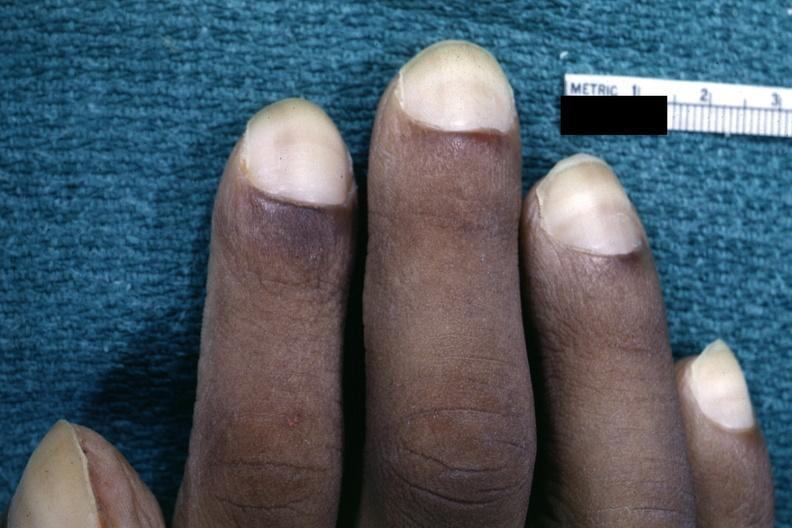what does this image show?
Answer the question using a single word or phrase. Close-up view of pulmonary osteoarthropathy 